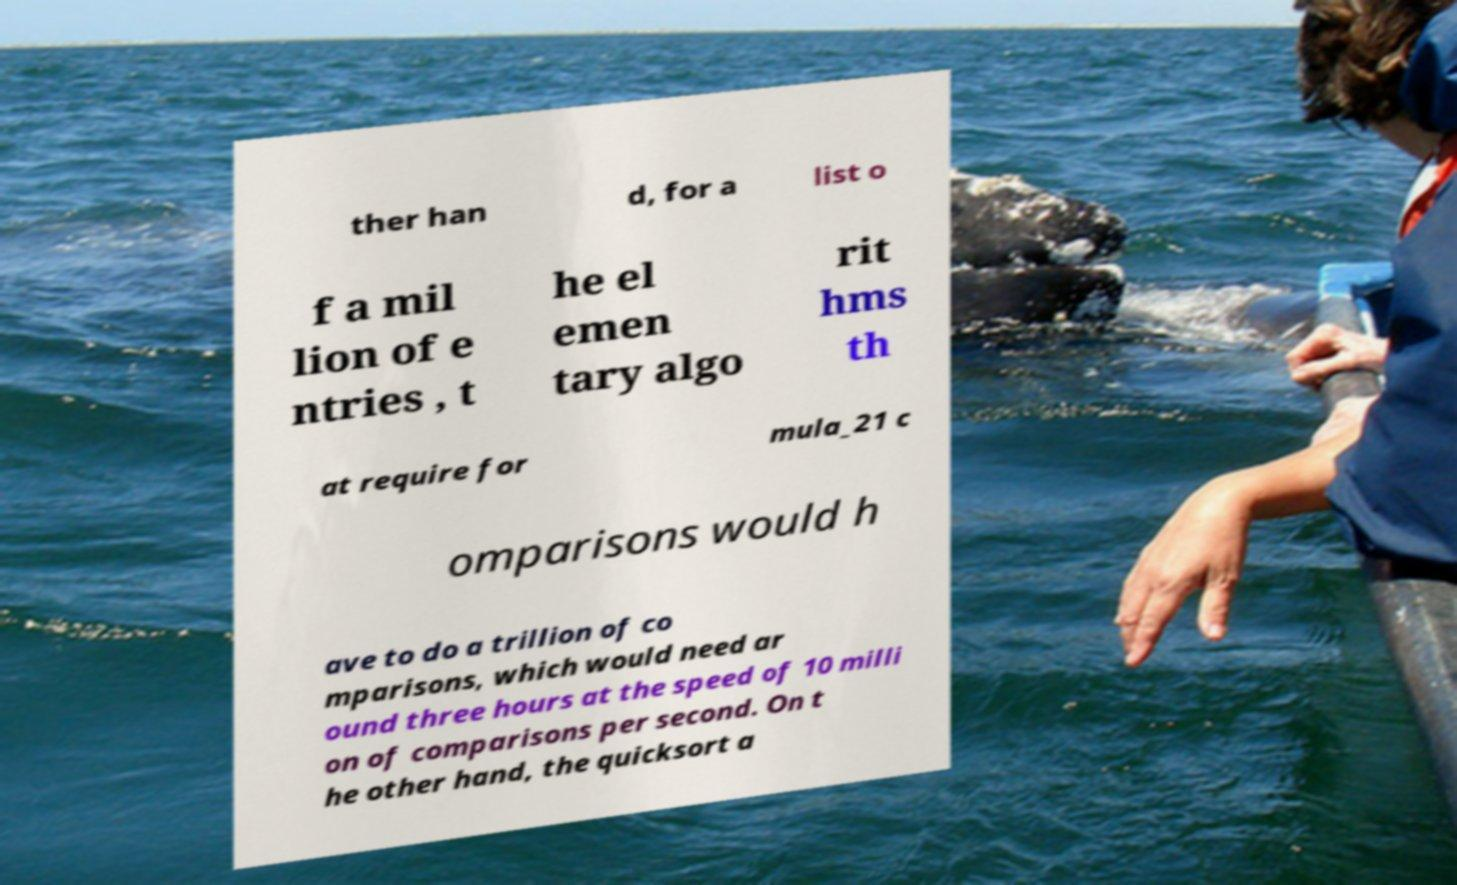What messages or text are displayed in this image? I need them in a readable, typed format. ther han d, for a list o f a mil lion of e ntries , t he el emen tary algo rit hms th at require for mula_21 c omparisons would h ave to do a trillion of co mparisons, which would need ar ound three hours at the speed of 10 milli on of comparisons per second. On t he other hand, the quicksort a 